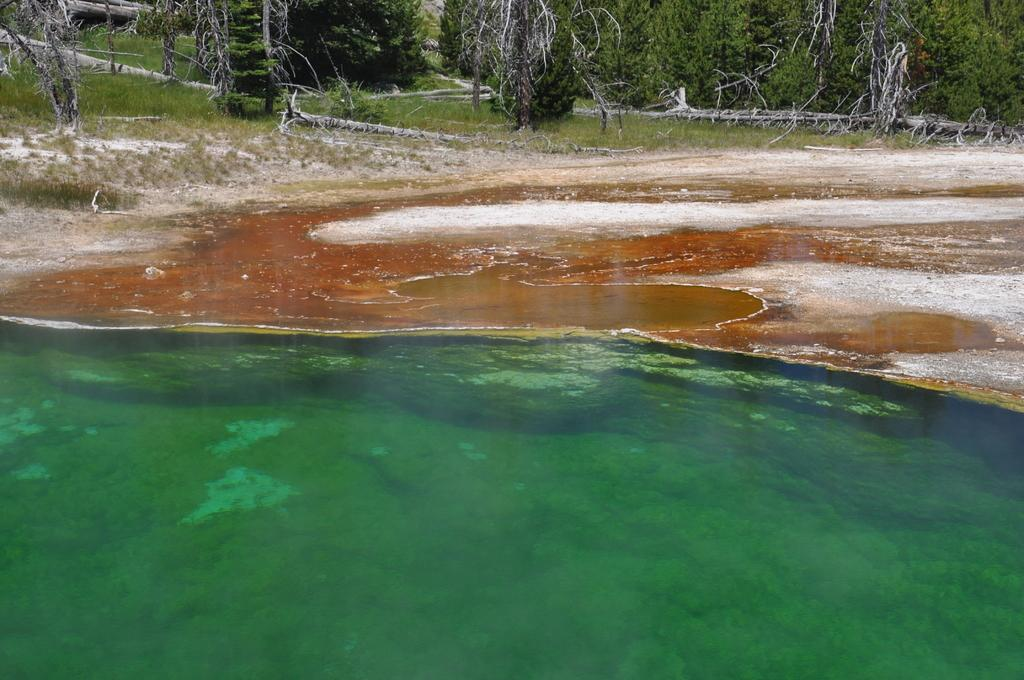What is the primary element visible in the image? There is water in the image. Can you describe the color of the water? The water has green and brown colors. What can be seen in the background of the image? There are trees and grass on the ground in the background of the image. Where is the rabbit carrying the parcel in the image? There is no rabbit or parcel present in the image. What type of river is visible in the image? There is no river visible in the image; it features water with green and brown colors. 